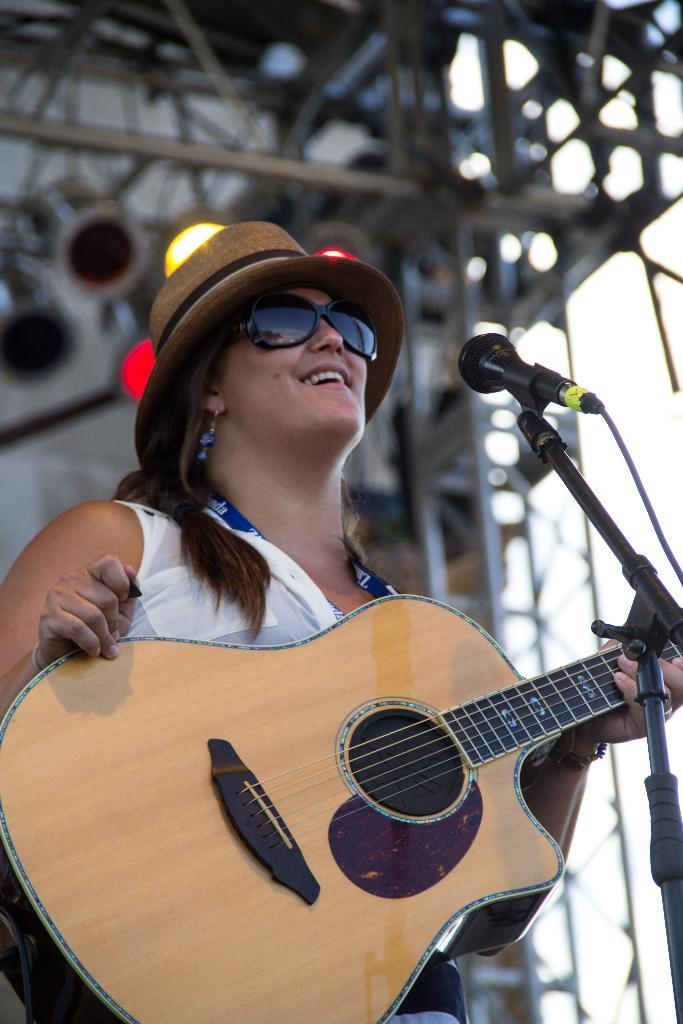Who is the main subject in the image? There is a lady in the image. What is the lady wearing? The lady is wearing a white dress and a hat. What object is the lady holding in the image? The lady is holding a guitar. What activity is the lady engaged in? The lady is playing the guitar in front of a microphone. Can you tell me how many buttons are on the cat's collar in the image? There is no cat present in the image, and therefore no collar or buttons to count. 